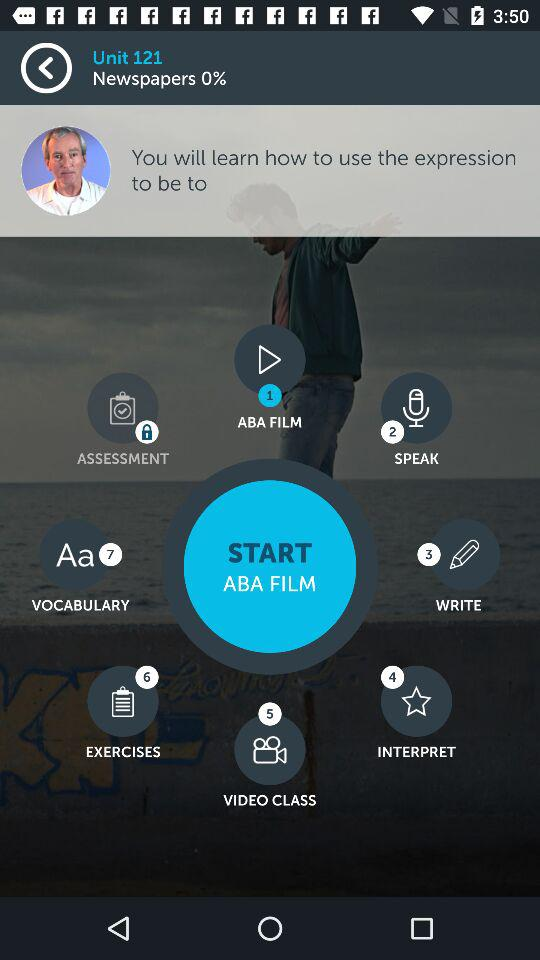What are the different stages of the ABA film shown? The different stages of the ABA film shown are "ABA FILM", "SPEAK", "WRITE", "INTERPRET", "VIDEO CLASS", "EXERCISES", "VOCABULARY" and "ASSESSMENT". 